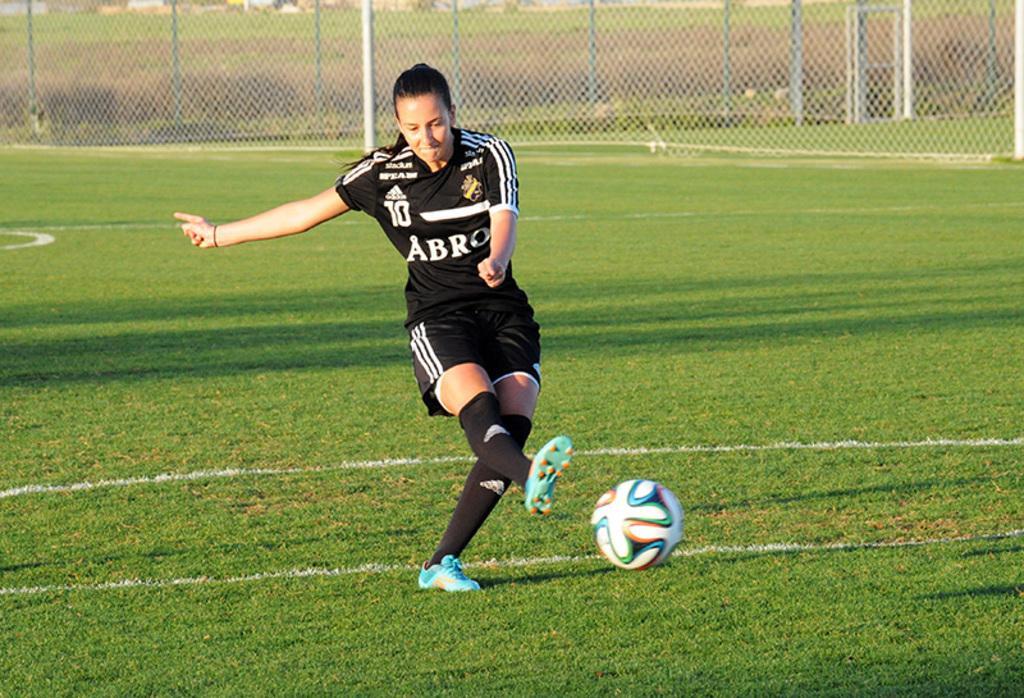Please provide a concise description of this image. In this image there is a person standing and kicking a ball, and in the background there is wire fencing, plants, grass. 